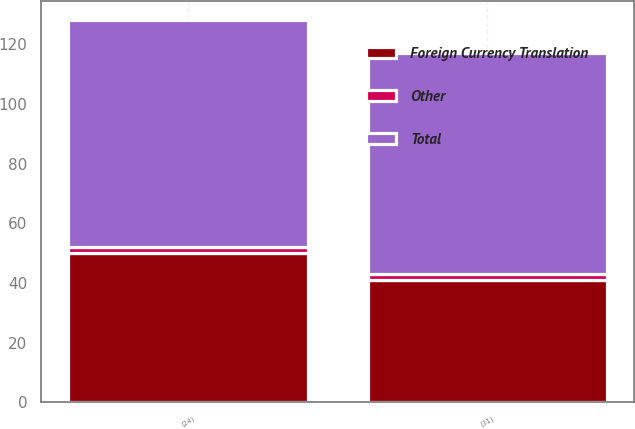<chart> <loc_0><loc_0><loc_500><loc_500><stacked_bar_chart><ecel><fcel>(31)<fcel>(24)<nl><fcel>Foreign Currency Translation<fcel>41<fcel>50<nl><fcel>Other<fcel>2<fcel>2<nl><fcel>Total<fcel>74<fcel>76<nl></chart> 